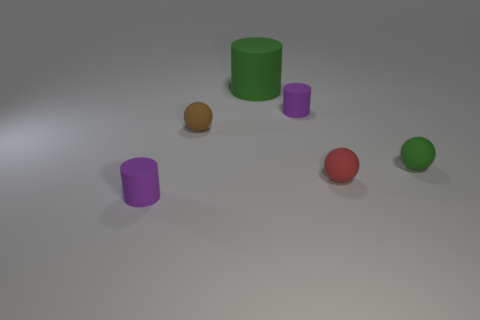Do the red object and the tiny brown matte thing have the same shape? yes 